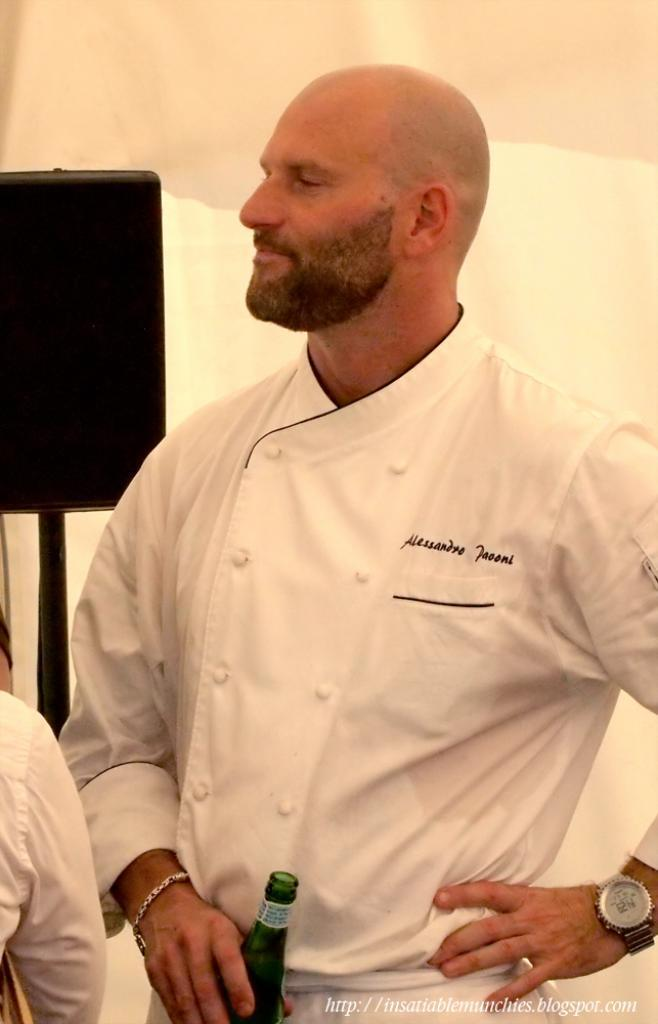Provide a one-sentence caption for the provided image. A picture of chef Alessandro Paooni holding a bottle. 